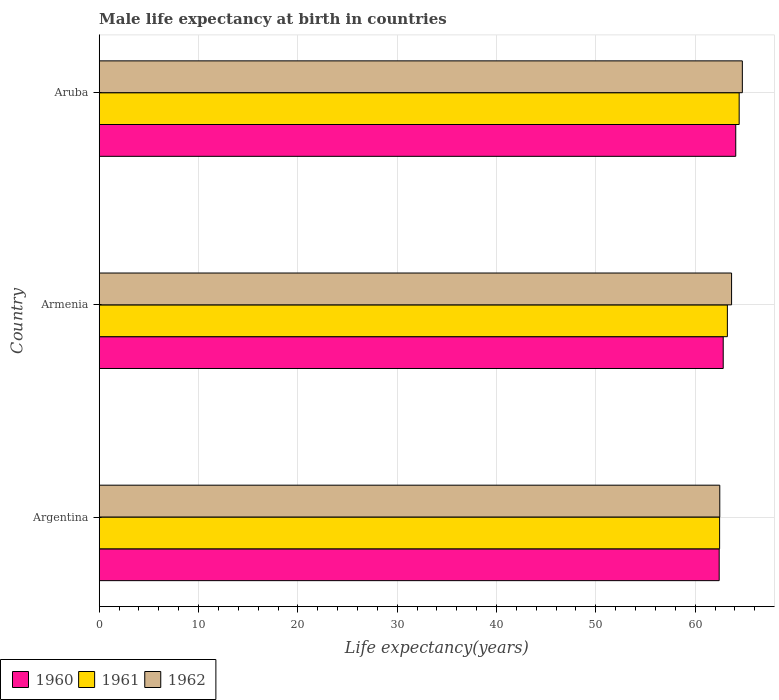How many groups of bars are there?
Provide a short and direct response. 3. Are the number of bars per tick equal to the number of legend labels?
Ensure brevity in your answer.  Yes. What is the male life expectancy at birth in 1960 in Aruba?
Ensure brevity in your answer.  64.08. Across all countries, what is the maximum male life expectancy at birth in 1962?
Make the answer very short. 64.75. Across all countries, what is the minimum male life expectancy at birth in 1961?
Offer a very short reply. 62.46. In which country was the male life expectancy at birth in 1960 maximum?
Your answer should be compact. Aruba. What is the total male life expectancy at birth in 1960 in the graph?
Offer a very short reply. 189.32. What is the difference between the male life expectancy at birth in 1962 in Argentina and that in Armenia?
Make the answer very short. -1.19. What is the difference between the male life expectancy at birth in 1962 in Aruba and the male life expectancy at birth in 1961 in Armenia?
Your answer should be compact. 1.51. What is the average male life expectancy at birth in 1962 per country?
Your response must be concise. 63.63. What is the difference between the male life expectancy at birth in 1961 and male life expectancy at birth in 1960 in Argentina?
Keep it short and to the point. 0.04. What is the ratio of the male life expectancy at birth in 1962 in Armenia to that in Aruba?
Give a very brief answer. 0.98. Is the difference between the male life expectancy at birth in 1961 in Armenia and Aruba greater than the difference between the male life expectancy at birth in 1960 in Armenia and Aruba?
Give a very brief answer. Yes. What is the difference between the highest and the second highest male life expectancy at birth in 1962?
Your response must be concise. 1.08. What is the difference between the highest and the lowest male life expectancy at birth in 1962?
Your answer should be very brief. 2.27. What does the 2nd bar from the top in Argentina represents?
Give a very brief answer. 1961. How many countries are there in the graph?
Give a very brief answer. 3. What is the difference between two consecutive major ticks on the X-axis?
Keep it short and to the point. 10. What is the title of the graph?
Offer a terse response. Male life expectancy at birth in countries. Does "2009" appear as one of the legend labels in the graph?
Your answer should be very brief. No. What is the label or title of the X-axis?
Provide a short and direct response. Life expectancy(years). What is the label or title of the Y-axis?
Your answer should be compact. Country. What is the Life expectancy(years) of 1960 in Argentina?
Your response must be concise. 62.42. What is the Life expectancy(years) in 1961 in Argentina?
Provide a succinct answer. 62.46. What is the Life expectancy(years) in 1962 in Argentina?
Make the answer very short. 62.48. What is the Life expectancy(years) in 1960 in Armenia?
Your answer should be very brief. 62.82. What is the Life expectancy(years) in 1961 in Armenia?
Offer a terse response. 63.24. What is the Life expectancy(years) in 1962 in Armenia?
Your answer should be compact. 63.66. What is the Life expectancy(years) in 1960 in Aruba?
Your answer should be very brief. 64.08. What is the Life expectancy(years) of 1961 in Aruba?
Keep it short and to the point. 64.43. What is the Life expectancy(years) of 1962 in Aruba?
Offer a very short reply. 64.75. Across all countries, what is the maximum Life expectancy(years) of 1960?
Your response must be concise. 64.08. Across all countries, what is the maximum Life expectancy(years) in 1961?
Your answer should be compact. 64.43. Across all countries, what is the maximum Life expectancy(years) in 1962?
Your answer should be compact. 64.75. Across all countries, what is the minimum Life expectancy(years) in 1960?
Provide a succinct answer. 62.42. Across all countries, what is the minimum Life expectancy(years) in 1961?
Your answer should be compact. 62.46. Across all countries, what is the minimum Life expectancy(years) of 1962?
Provide a succinct answer. 62.48. What is the total Life expectancy(years) in 1960 in the graph?
Your response must be concise. 189.32. What is the total Life expectancy(years) in 1961 in the graph?
Your answer should be compact. 190.13. What is the total Life expectancy(years) in 1962 in the graph?
Make the answer very short. 190.89. What is the difference between the Life expectancy(years) in 1960 in Argentina and that in Armenia?
Your answer should be compact. -0.41. What is the difference between the Life expectancy(years) in 1961 in Argentina and that in Armenia?
Your answer should be very brief. -0.78. What is the difference between the Life expectancy(years) in 1962 in Argentina and that in Armenia?
Your response must be concise. -1.19. What is the difference between the Life expectancy(years) in 1960 in Argentina and that in Aruba?
Provide a succinct answer. -1.67. What is the difference between the Life expectancy(years) of 1961 in Argentina and that in Aruba?
Provide a short and direct response. -1.97. What is the difference between the Life expectancy(years) of 1962 in Argentina and that in Aruba?
Provide a succinct answer. -2.27. What is the difference between the Life expectancy(years) in 1960 in Armenia and that in Aruba?
Ensure brevity in your answer.  -1.26. What is the difference between the Life expectancy(years) in 1961 in Armenia and that in Aruba?
Provide a succinct answer. -1.19. What is the difference between the Life expectancy(years) in 1962 in Armenia and that in Aruba?
Give a very brief answer. -1.08. What is the difference between the Life expectancy(years) in 1960 in Argentina and the Life expectancy(years) in 1961 in Armenia?
Keep it short and to the point. -0.82. What is the difference between the Life expectancy(years) of 1960 in Argentina and the Life expectancy(years) of 1962 in Armenia?
Offer a very short reply. -1.25. What is the difference between the Life expectancy(years) in 1961 in Argentina and the Life expectancy(years) in 1962 in Armenia?
Offer a very short reply. -1.21. What is the difference between the Life expectancy(years) of 1960 in Argentina and the Life expectancy(years) of 1961 in Aruba?
Provide a succinct answer. -2.01. What is the difference between the Life expectancy(years) in 1960 in Argentina and the Life expectancy(years) in 1962 in Aruba?
Give a very brief answer. -2.33. What is the difference between the Life expectancy(years) in 1961 in Argentina and the Life expectancy(years) in 1962 in Aruba?
Offer a terse response. -2.29. What is the difference between the Life expectancy(years) in 1960 in Armenia and the Life expectancy(years) in 1961 in Aruba?
Give a very brief answer. -1.61. What is the difference between the Life expectancy(years) in 1960 in Armenia and the Life expectancy(years) in 1962 in Aruba?
Your response must be concise. -1.93. What is the difference between the Life expectancy(years) in 1961 in Armenia and the Life expectancy(years) in 1962 in Aruba?
Provide a short and direct response. -1.51. What is the average Life expectancy(years) in 1960 per country?
Ensure brevity in your answer.  63.11. What is the average Life expectancy(years) of 1961 per country?
Make the answer very short. 63.38. What is the average Life expectancy(years) of 1962 per country?
Give a very brief answer. 63.63. What is the difference between the Life expectancy(years) in 1960 and Life expectancy(years) in 1961 in Argentina?
Give a very brief answer. -0.04. What is the difference between the Life expectancy(years) in 1960 and Life expectancy(years) in 1962 in Argentina?
Give a very brief answer. -0.06. What is the difference between the Life expectancy(years) of 1961 and Life expectancy(years) of 1962 in Argentina?
Make the answer very short. -0.02. What is the difference between the Life expectancy(years) in 1960 and Life expectancy(years) in 1961 in Armenia?
Offer a very short reply. -0.42. What is the difference between the Life expectancy(years) in 1960 and Life expectancy(years) in 1962 in Armenia?
Provide a succinct answer. -0.84. What is the difference between the Life expectancy(years) of 1961 and Life expectancy(years) of 1962 in Armenia?
Offer a terse response. -0.42. What is the difference between the Life expectancy(years) in 1960 and Life expectancy(years) in 1961 in Aruba?
Make the answer very short. -0.34. What is the difference between the Life expectancy(years) in 1960 and Life expectancy(years) in 1962 in Aruba?
Your answer should be compact. -0.66. What is the difference between the Life expectancy(years) of 1961 and Life expectancy(years) of 1962 in Aruba?
Your response must be concise. -0.32. What is the ratio of the Life expectancy(years) in 1962 in Argentina to that in Armenia?
Provide a succinct answer. 0.98. What is the ratio of the Life expectancy(years) in 1960 in Argentina to that in Aruba?
Provide a succinct answer. 0.97. What is the ratio of the Life expectancy(years) in 1961 in Argentina to that in Aruba?
Make the answer very short. 0.97. What is the ratio of the Life expectancy(years) of 1962 in Argentina to that in Aruba?
Give a very brief answer. 0.96. What is the ratio of the Life expectancy(years) in 1960 in Armenia to that in Aruba?
Provide a succinct answer. 0.98. What is the ratio of the Life expectancy(years) in 1961 in Armenia to that in Aruba?
Provide a short and direct response. 0.98. What is the ratio of the Life expectancy(years) of 1962 in Armenia to that in Aruba?
Provide a succinct answer. 0.98. What is the difference between the highest and the second highest Life expectancy(years) in 1960?
Provide a succinct answer. 1.26. What is the difference between the highest and the second highest Life expectancy(years) of 1961?
Ensure brevity in your answer.  1.19. What is the difference between the highest and the second highest Life expectancy(years) in 1962?
Offer a very short reply. 1.08. What is the difference between the highest and the lowest Life expectancy(years) of 1960?
Your answer should be compact. 1.67. What is the difference between the highest and the lowest Life expectancy(years) in 1961?
Provide a succinct answer. 1.97. What is the difference between the highest and the lowest Life expectancy(years) of 1962?
Ensure brevity in your answer.  2.27. 